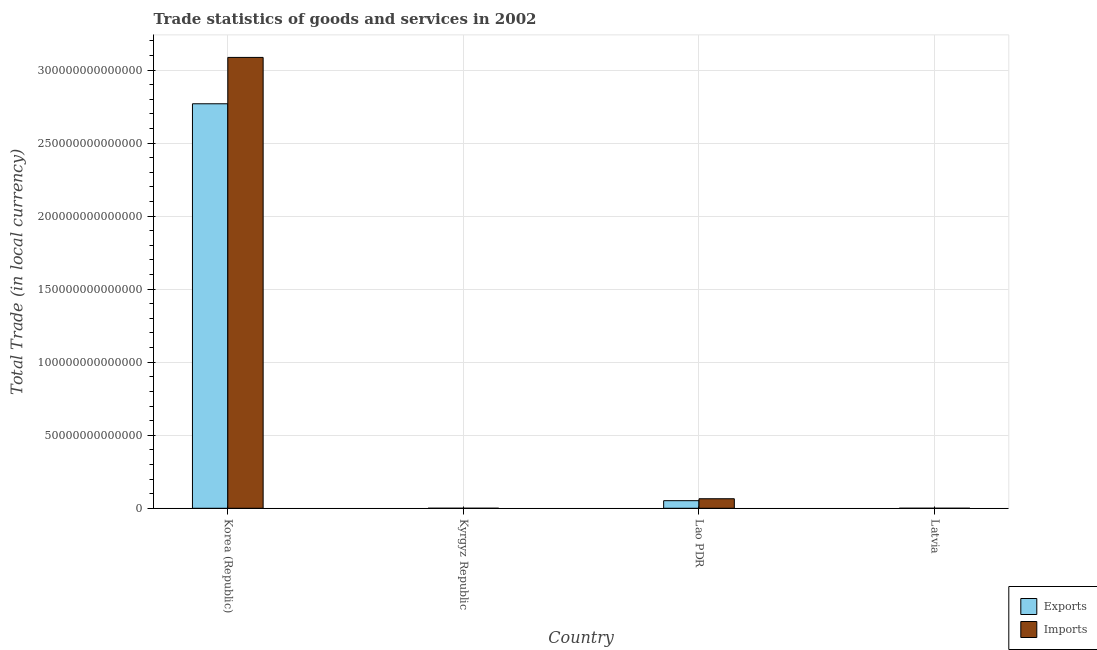Are the number of bars on each tick of the X-axis equal?
Provide a short and direct response. Yes. How many bars are there on the 3rd tick from the right?
Offer a terse response. 2. What is the label of the 2nd group of bars from the left?
Offer a very short reply. Kyrgyz Republic. In how many cases, is the number of bars for a given country not equal to the number of legend labels?
Make the answer very short. 0. What is the export of goods and services in Latvia?
Make the answer very short. 5.33e+09. Across all countries, what is the maximum imports of goods and services?
Provide a short and direct response. 3.09e+14. Across all countries, what is the minimum imports of goods and services?
Your answer should be very brief. 5.51e+09. In which country was the export of goods and services minimum?
Offer a very short reply. Latvia. What is the total imports of goods and services in the graph?
Give a very brief answer. 3.15e+14. What is the difference between the imports of goods and services in Kyrgyz Republic and that in Lao PDR?
Ensure brevity in your answer.  -6.52e+12. What is the difference between the export of goods and services in Kyrgyz Republic and the imports of goods and services in Latvia?
Make the answer very short. -5.96e+08. What is the average export of goods and services per country?
Your answer should be very brief. 7.05e+13. What is the difference between the export of goods and services and imports of goods and services in Lao PDR?
Give a very brief answer. -1.33e+12. What is the ratio of the imports of goods and services in Lao PDR to that in Latvia?
Ensure brevity in your answer.  1018.73. Is the export of goods and services in Kyrgyz Republic less than that in Lao PDR?
Your answer should be compact. Yes. Is the difference between the export of goods and services in Kyrgyz Republic and Latvia greater than the difference between the imports of goods and services in Kyrgyz Republic and Latvia?
Your response must be concise. Yes. What is the difference between the highest and the second highest export of goods and services?
Your answer should be compact. 2.72e+14. What is the difference between the highest and the lowest export of goods and services?
Make the answer very short. 2.77e+14. In how many countries, is the imports of goods and services greater than the average imports of goods and services taken over all countries?
Ensure brevity in your answer.  1. What does the 2nd bar from the left in Latvia represents?
Give a very brief answer. Imports. What does the 1st bar from the right in Kyrgyz Republic represents?
Offer a very short reply. Imports. How many bars are there?
Your response must be concise. 8. How many countries are there in the graph?
Keep it short and to the point. 4. What is the difference between two consecutive major ticks on the Y-axis?
Give a very brief answer. 5.00e+13. Are the values on the major ticks of Y-axis written in scientific E-notation?
Make the answer very short. No. Does the graph contain any zero values?
Your answer should be compact. No. Does the graph contain grids?
Ensure brevity in your answer.  Yes. How are the legend labels stacked?
Ensure brevity in your answer.  Vertical. What is the title of the graph?
Ensure brevity in your answer.  Trade statistics of goods and services in 2002. Does "Age 65(male)" appear as one of the legend labels in the graph?
Ensure brevity in your answer.  No. What is the label or title of the Y-axis?
Your response must be concise. Total Trade (in local currency). What is the Total Trade (in local currency) in Exports in Korea (Republic)?
Your answer should be very brief. 2.77e+14. What is the Total Trade (in local currency) of Imports in Korea (Republic)?
Ensure brevity in your answer.  3.09e+14. What is the Total Trade (in local currency) of Exports in Kyrgyz Republic?
Offer a very short reply. 5.81e+09. What is the Total Trade (in local currency) in Imports in Kyrgyz Republic?
Your response must be concise. 5.51e+09. What is the Total Trade (in local currency) of Exports in Lao PDR?
Your answer should be compact. 5.20e+12. What is the Total Trade (in local currency) of Imports in Lao PDR?
Ensure brevity in your answer.  6.52e+12. What is the Total Trade (in local currency) in Exports in Latvia?
Provide a short and direct response. 5.33e+09. What is the Total Trade (in local currency) of Imports in Latvia?
Your answer should be very brief. 6.40e+09. Across all countries, what is the maximum Total Trade (in local currency) in Exports?
Give a very brief answer. 2.77e+14. Across all countries, what is the maximum Total Trade (in local currency) in Imports?
Offer a very short reply. 3.09e+14. Across all countries, what is the minimum Total Trade (in local currency) in Exports?
Keep it short and to the point. 5.33e+09. Across all countries, what is the minimum Total Trade (in local currency) of Imports?
Ensure brevity in your answer.  5.51e+09. What is the total Total Trade (in local currency) in Exports in the graph?
Provide a short and direct response. 2.82e+14. What is the total Total Trade (in local currency) in Imports in the graph?
Your answer should be very brief. 3.15e+14. What is the difference between the Total Trade (in local currency) of Exports in Korea (Republic) and that in Kyrgyz Republic?
Offer a terse response. 2.77e+14. What is the difference between the Total Trade (in local currency) of Imports in Korea (Republic) and that in Kyrgyz Republic?
Make the answer very short. 3.09e+14. What is the difference between the Total Trade (in local currency) of Exports in Korea (Republic) and that in Lao PDR?
Offer a terse response. 2.72e+14. What is the difference between the Total Trade (in local currency) in Imports in Korea (Republic) and that in Lao PDR?
Provide a short and direct response. 3.02e+14. What is the difference between the Total Trade (in local currency) in Exports in Korea (Republic) and that in Latvia?
Give a very brief answer. 2.77e+14. What is the difference between the Total Trade (in local currency) of Imports in Korea (Republic) and that in Latvia?
Make the answer very short. 3.09e+14. What is the difference between the Total Trade (in local currency) in Exports in Kyrgyz Republic and that in Lao PDR?
Provide a short and direct response. -5.19e+12. What is the difference between the Total Trade (in local currency) of Imports in Kyrgyz Republic and that in Lao PDR?
Provide a succinct answer. -6.52e+12. What is the difference between the Total Trade (in local currency) in Exports in Kyrgyz Republic and that in Latvia?
Keep it short and to the point. 4.80e+08. What is the difference between the Total Trade (in local currency) of Imports in Kyrgyz Republic and that in Latvia?
Offer a very short reply. -8.93e+08. What is the difference between the Total Trade (in local currency) in Exports in Lao PDR and that in Latvia?
Your answer should be very brief. 5.19e+12. What is the difference between the Total Trade (in local currency) of Imports in Lao PDR and that in Latvia?
Give a very brief answer. 6.52e+12. What is the difference between the Total Trade (in local currency) in Exports in Korea (Republic) and the Total Trade (in local currency) in Imports in Kyrgyz Republic?
Your response must be concise. 2.77e+14. What is the difference between the Total Trade (in local currency) of Exports in Korea (Republic) and the Total Trade (in local currency) of Imports in Lao PDR?
Make the answer very short. 2.70e+14. What is the difference between the Total Trade (in local currency) in Exports in Korea (Republic) and the Total Trade (in local currency) in Imports in Latvia?
Give a very brief answer. 2.77e+14. What is the difference between the Total Trade (in local currency) in Exports in Kyrgyz Republic and the Total Trade (in local currency) in Imports in Lao PDR?
Offer a very short reply. -6.52e+12. What is the difference between the Total Trade (in local currency) of Exports in Kyrgyz Republic and the Total Trade (in local currency) of Imports in Latvia?
Keep it short and to the point. -5.96e+08. What is the difference between the Total Trade (in local currency) in Exports in Lao PDR and the Total Trade (in local currency) in Imports in Latvia?
Provide a succinct answer. 5.19e+12. What is the average Total Trade (in local currency) in Exports per country?
Keep it short and to the point. 7.05e+13. What is the average Total Trade (in local currency) of Imports per country?
Provide a succinct answer. 7.88e+13. What is the difference between the Total Trade (in local currency) in Exports and Total Trade (in local currency) in Imports in Korea (Republic)?
Provide a succinct answer. -3.17e+13. What is the difference between the Total Trade (in local currency) in Exports and Total Trade (in local currency) in Imports in Kyrgyz Republic?
Your answer should be compact. 2.97e+08. What is the difference between the Total Trade (in local currency) in Exports and Total Trade (in local currency) in Imports in Lao PDR?
Ensure brevity in your answer.  -1.33e+12. What is the difference between the Total Trade (in local currency) in Exports and Total Trade (in local currency) in Imports in Latvia?
Your answer should be compact. -1.08e+09. What is the ratio of the Total Trade (in local currency) in Exports in Korea (Republic) to that in Kyrgyz Republic?
Provide a short and direct response. 4.77e+04. What is the ratio of the Total Trade (in local currency) in Imports in Korea (Republic) to that in Kyrgyz Republic?
Keep it short and to the point. 5.60e+04. What is the ratio of the Total Trade (in local currency) in Exports in Korea (Republic) to that in Lao PDR?
Offer a terse response. 53.29. What is the ratio of the Total Trade (in local currency) of Imports in Korea (Republic) to that in Lao PDR?
Offer a very short reply. 47.31. What is the ratio of the Total Trade (in local currency) in Exports in Korea (Republic) to that in Latvia?
Provide a succinct answer. 5.20e+04. What is the ratio of the Total Trade (in local currency) of Imports in Korea (Republic) to that in Latvia?
Provide a short and direct response. 4.82e+04. What is the ratio of the Total Trade (in local currency) of Exports in Kyrgyz Republic to that in Lao PDR?
Offer a very short reply. 0. What is the ratio of the Total Trade (in local currency) in Imports in Kyrgyz Republic to that in Lao PDR?
Your answer should be compact. 0. What is the ratio of the Total Trade (in local currency) of Exports in Kyrgyz Republic to that in Latvia?
Provide a short and direct response. 1.09. What is the ratio of the Total Trade (in local currency) of Imports in Kyrgyz Republic to that in Latvia?
Your answer should be compact. 0.86. What is the ratio of the Total Trade (in local currency) of Exports in Lao PDR to that in Latvia?
Offer a terse response. 975.29. What is the ratio of the Total Trade (in local currency) of Imports in Lao PDR to that in Latvia?
Ensure brevity in your answer.  1018.73. What is the difference between the highest and the second highest Total Trade (in local currency) in Exports?
Provide a succinct answer. 2.72e+14. What is the difference between the highest and the second highest Total Trade (in local currency) of Imports?
Your answer should be very brief. 3.02e+14. What is the difference between the highest and the lowest Total Trade (in local currency) of Exports?
Provide a succinct answer. 2.77e+14. What is the difference between the highest and the lowest Total Trade (in local currency) in Imports?
Ensure brevity in your answer.  3.09e+14. 